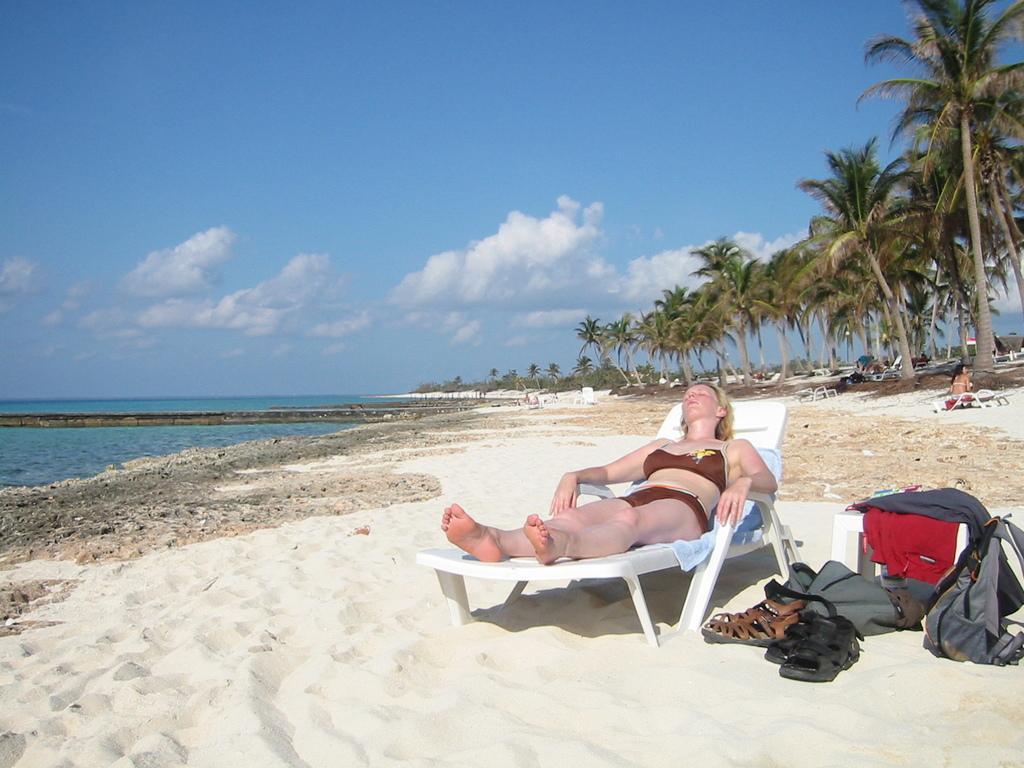How would you summarize this image in a sentence or two? In front of the image there is a person sleeping on the chair. Beside her there is a stool. On top of it there are clothes. There are bags and sandals. Behind her there is a person sitting on the chair. At the bottom of the image there is a sand on the surface. On the left side of the image there is water. In the background of the image there are trees, chairs. At the top of the image there are clouds in the sky. 